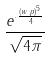<formula> <loc_0><loc_0><loc_500><loc_500>\frac { e ^ { \cdot \frac { ( w \cdot p ) ^ { 5 } } { 4 } } } { \sqrt { 4 \pi } }</formula> 